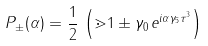<formula> <loc_0><loc_0><loc_500><loc_500>P _ { \pm } ( \alpha ) = \frac { 1 } { 2 } \, \left ( \mathbb { m } { 1 } \pm \gamma _ { 0 } \, e ^ { i \alpha \gamma _ { 5 } \tau ^ { 3 } } \right )</formula> 